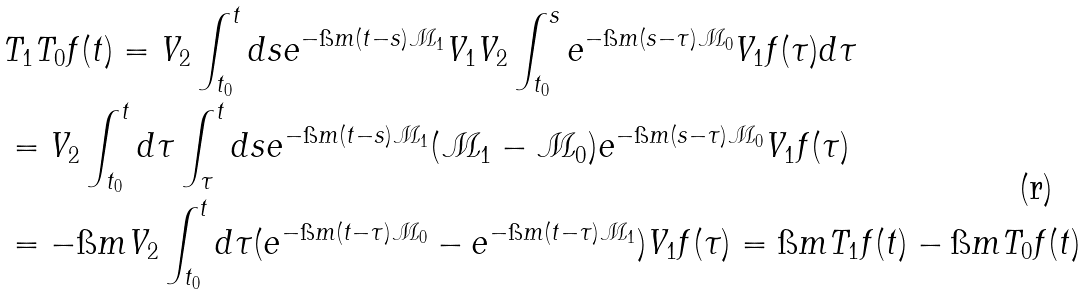<formula> <loc_0><loc_0><loc_500><loc_500>& T _ { 1 } T _ { 0 } f ( t ) = V _ { 2 } \int _ { t _ { 0 } } ^ { t } d s e ^ { - \i m ( t - s ) \mathcal { M } _ { 1 } } V _ { 1 } V _ { 2 } \int _ { t _ { 0 } } ^ { s } e ^ { - \i m ( s - \tau ) \mathcal { M } _ { 0 } } V _ { 1 } f ( \tau ) d \tau \\ & = V _ { 2 } \int _ { t _ { 0 } } ^ { t } d \tau \int _ { \tau } ^ { t } d s e ^ { - \i m ( t - s ) \mathcal { M } _ { 1 } } ( \mathcal { M } _ { 1 } - \mathcal { M } _ { 0 } ) e ^ { - \i m ( s - \tau ) \mathcal { M } _ { 0 } } V _ { 1 } f ( \tau ) \\ & = - \i m V _ { 2 } \int _ { t _ { 0 } } ^ { t } d \tau ( e ^ { - \i m ( t - \tau ) \mathcal { M } _ { 0 } } - e ^ { - \i m ( t - \tau ) \mathcal { M } _ { 1 } } ) V _ { 1 } f ( \tau ) = \i m T _ { 1 } f ( t ) - \i m T _ { 0 } f ( t )</formula> 